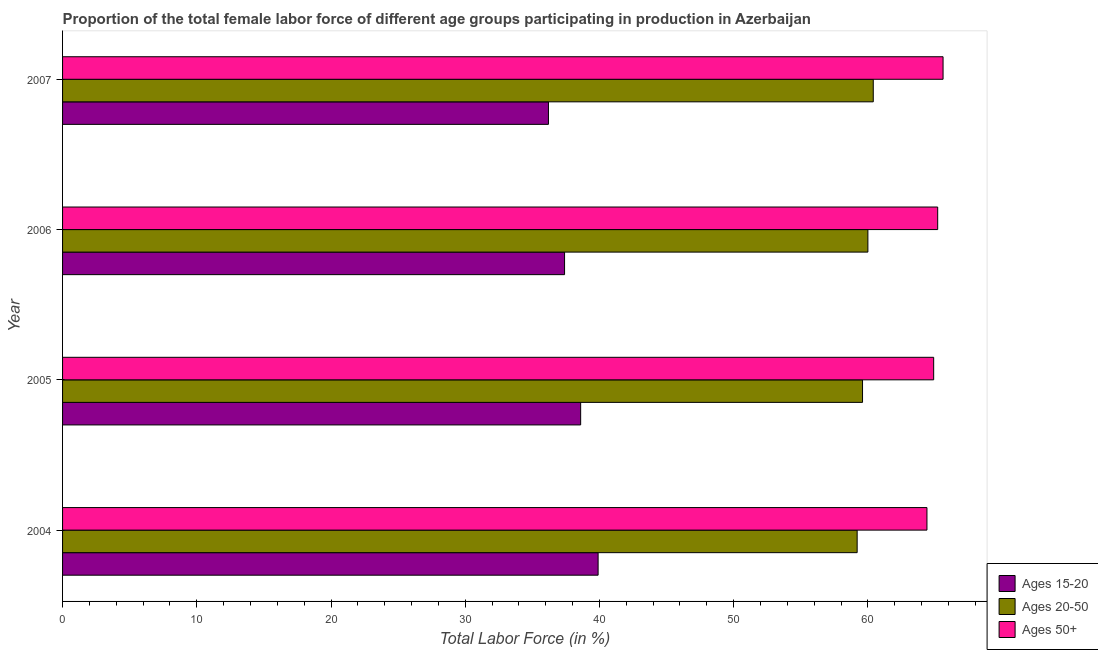How many different coloured bars are there?
Keep it short and to the point. 3. How many groups of bars are there?
Provide a succinct answer. 4. In how many cases, is the number of bars for a given year not equal to the number of legend labels?
Ensure brevity in your answer.  0. What is the percentage of female labor force within the age group 15-20 in 2005?
Provide a succinct answer. 38.6. Across all years, what is the maximum percentage of female labor force within the age group 15-20?
Give a very brief answer. 39.9. Across all years, what is the minimum percentage of female labor force within the age group 20-50?
Your response must be concise. 59.2. In which year was the percentage of female labor force within the age group 20-50 maximum?
Provide a short and direct response. 2007. In which year was the percentage of female labor force within the age group 20-50 minimum?
Your response must be concise. 2004. What is the total percentage of female labor force within the age group 15-20 in the graph?
Give a very brief answer. 152.1. What is the average percentage of female labor force within the age group 20-50 per year?
Offer a terse response. 59.8. In the year 2006, what is the difference between the percentage of female labor force within the age group 15-20 and percentage of female labor force within the age group 20-50?
Provide a short and direct response. -22.6. In how many years, is the percentage of female labor force within the age group 15-20 greater than 66 %?
Keep it short and to the point. 0. What is the difference between the highest and the second highest percentage of female labor force within the age group 15-20?
Give a very brief answer. 1.3. What is the difference between the highest and the lowest percentage of female labor force above age 50?
Offer a very short reply. 1.2. What does the 1st bar from the top in 2004 represents?
Offer a very short reply. Ages 50+. What does the 2nd bar from the bottom in 2007 represents?
Your answer should be very brief. Ages 20-50. Is it the case that in every year, the sum of the percentage of female labor force within the age group 15-20 and percentage of female labor force within the age group 20-50 is greater than the percentage of female labor force above age 50?
Offer a very short reply. Yes. How many bars are there?
Offer a terse response. 12. How many years are there in the graph?
Your response must be concise. 4. What is the difference between two consecutive major ticks on the X-axis?
Provide a succinct answer. 10. Are the values on the major ticks of X-axis written in scientific E-notation?
Give a very brief answer. No. How are the legend labels stacked?
Your response must be concise. Vertical. What is the title of the graph?
Make the answer very short. Proportion of the total female labor force of different age groups participating in production in Azerbaijan. Does "Ages 50+" appear as one of the legend labels in the graph?
Offer a terse response. Yes. What is the label or title of the Y-axis?
Offer a very short reply. Year. What is the Total Labor Force (in %) of Ages 15-20 in 2004?
Give a very brief answer. 39.9. What is the Total Labor Force (in %) in Ages 20-50 in 2004?
Ensure brevity in your answer.  59.2. What is the Total Labor Force (in %) in Ages 50+ in 2004?
Your response must be concise. 64.4. What is the Total Labor Force (in %) of Ages 15-20 in 2005?
Keep it short and to the point. 38.6. What is the Total Labor Force (in %) of Ages 20-50 in 2005?
Make the answer very short. 59.6. What is the Total Labor Force (in %) of Ages 50+ in 2005?
Your response must be concise. 64.9. What is the Total Labor Force (in %) of Ages 15-20 in 2006?
Ensure brevity in your answer.  37.4. What is the Total Labor Force (in %) in Ages 50+ in 2006?
Offer a very short reply. 65.2. What is the Total Labor Force (in %) in Ages 15-20 in 2007?
Provide a succinct answer. 36.2. What is the Total Labor Force (in %) in Ages 20-50 in 2007?
Your response must be concise. 60.4. What is the Total Labor Force (in %) in Ages 50+ in 2007?
Give a very brief answer. 65.6. Across all years, what is the maximum Total Labor Force (in %) in Ages 15-20?
Make the answer very short. 39.9. Across all years, what is the maximum Total Labor Force (in %) in Ages 20-50?
Your response must be concise. 60.4. Across all years, what is the maximum Total Labor Force (in %) of Ages 50+?
Keep it short and to the point. 65.6. Across all years, what is the minimum Total Labor Force (in %) in Ages 15-20?
Make the answer very short. 36.2. Across all years, what is the minimum Total Labor Force (in %) of Ages 20-50?
Your answer should be very brief. 59.2. Across all years, what is the minimum Total Labor Force (in %) of Ages 50+?
Offer a terse response. 64.4. What is the total Total Labor Force (in %) in Ages 15-20 in the graph?
Your response must be concise. 152.1. What is the total Total Labor Force (in %) in Ages 20-50 in the graph?
Provide a succinct answer. 239.2. What is the total Total Labor Force (in %) in Ages 50+ in the graph?
Provide a short and direct response. 260.1. What is the difference between the Total Labor Force (in %) of Ages 20-50 in 2004 and that in 2005?
Provide a succinct answer. -0.4. What is the difference between the Total Labor Force (in %) of Ages 50+ in 2004 and that in 2005?
Offer a very short reply. -0.5. What is the difference between the Total Labor Force (in %) of Ages 20-50 in 2004 and that in 2006?
Make the answer very short. -0.8. What is the difference between the Total Labor Force (in %) of Ages 50+ in 2004 and that in 2006?
Offer a terse response. -0.8. What is the difference between the Total Labor Force (in %) of Ages 15-20 in 2004 and that in 2007?
Offer a very short reply. 3.7. What is the difference between the Total Labor Force (in %) of Ages 20-50 in 2004 and that in 2007?
Keep it short and to the point. -1.2. What is the difference between the Total Labor Force (in %) of Ages 50+ in 2004 and that in 2007?
Your answer should be very brief. -1.2. What is the difference between the Total Labor Force (in %) of Ages 15-20 in 2005 and that in 2006?
Provide a short and direct response. 1.2. What is the difference between the Total Labor Force (in %) in Ages 50+ in 2005 and that in 2006?
Ensure brevity in your answer.  -0.3. What is the difference between the Total Labor Force (in %) of Ages 20-50 in 2005 and that in 2007?
Your answer should be very brief. -0.8. What is the difference between the Total Labor Force (in %) of Ages 50+ in 2005 and that in 2007?
Your answer should be very brief. -0.7. What is the difference between the Total Labor Force (in %) of Ages 15-20 in 2006 and that in 2007?
Keep it short and to the point. 1.2. What is the difference between the Total Labor Force (in %) in Ages 20-50 in 2006 and that in 2007?
Offer a very short reply. -0.4. What is the difference between the Total Labor Force (in %) in Ages 15-20 in 2004 and the Total Labor Force (in %) in Ages 20-50 in 2005?
Ensure brevity in your answer.  -19.7. What is the difference between the Total Labor Force (in %) in Ages 15-20 in 2004 and the Total Labor Force (in %) in Ages 50+ in 2005?
Give a very brief answer. -25. What is the difference between the Total Labor Force (in %) in Ages 20-50 in 2004 and the Total Labor Force (in %) in Ages 50+ in 2005?
Your answer should be very brief. -5.7. What is the difference between the Total Labor Force (in %) in Ages 15-20 in 2004 and the Total Labor Force (in %) in Ages 20-50 in 2006?
Your answer should be compact. -20.1. What is the difference between the Total Labor Force (in %) of Ages 15-20 in 2004 and the Total Labor Force (in %) of Ages 50+ in 2006?
Your answer should be compact. -25.3. What is the difference between the Total Labor Force (in %) in Ages 15-20 in 2004 and the Total Labor Force (in %) in Ages 20-50 in 2007?
Offer a terse response. -20.5. What is the difference between the Total Labor Force (in %) of Ages 15-20 in 2004 and the Total Labor Force (in %) of Ages 50+ in 2007?
Give a very brief answer. -25.7. What is the difference between the Total Labor Force (in %) in Ages 15-20 in 2005 and the Total Labor Force (in %) in Ages 20-50 in 2006?
Provide a succinct answer. -21.4. What is the difference between the Total Labor Force (in %) of Ages 15-20 in 2005 and the Total Labor Force (in %) of Ages 50+ in 2006?
Your response must be concise. -26.6. What is the difference between the Total Labor Force (in %) in Ages 15-20 in 2005 and the Total Labor Force (in %) in Ages 20-50 in 2007?
Your answer should be very brief. -21.8. What is the difference between the Total Labor Force (in %) in Ages 20-50 in 2005 and the Total Labor Force (in %) in Ages 50+ in 2007?
Offer a terse response. -6. What is the difference between the Total Labor Force (in %) in Ages 15-20 in 2006 and the Total Labor Force (in %) in Ages 50+ in 2007?
Provide a succinct answer. -28.2. What is the difference between the Total Labor Force (in %) of Ages 20-50 in 2006 and the Total Labor Force (in %) of Ages 50+ in 2007?
Make the answer very short. -5.6. What is the average Total Labor Force (in %) in Ages 15-20 per year?
Provide a succinct answer. 38.02. What is the average Total Labor Force (in %) of Ages 20-50 per year?
Keep it short and to the point. 59.8. What is the average Total Labor Force (in %) of Ages 50+ per year?
Give a very brief answer. 65.03. In the year 2004, what is the difference between the Total Labor Force (in %) of Ages 15-20 and Total Labor Force (in %) of Ages 20-50?
Ensure brevity in your answer.  -19.3. In the year 2004, what is the difference between the Total Labor Force (in %) in Ages 15-20 and Total Labor Force (in %) in Ages 50+?
Your answer should be very brief. -24.5. In the year 2004, what is the difference between the Total Labor Force (in %) of Ages 20-50 and Total Labor Force (in %) of Ages 50+?
Offer a very short reply. -5.2. In the year 2005, what is the difference between the Total Labor Force (in %) of Ages 15-20 and Total Labor Force (in %) of Ages 50+?
Your answer should be very brief. -26.3. In the year 2005, what is the difference between the Total Labor Force (in %) of Ages 20-50 and Total Labor Force (in %) of Ages 50+?
Your answer should be compact. -5.3. In the year 2006, what is the difference between the Total Labor Force (in %) in Ages 15-20 and Total Labor Force (in %) in Ages 20-50?
Offer a terse response. -22.6. In the year 2006, what is the difference between the Total Labor Force (in %) of Ages 15-20 and Total Labor Force (in %) of Ages 50+?
Provide a succinct answer. -27.8. In the year 2006, what is the difference between the Total Labor Force (in %) of Ages 20-50 and Total Labor Force (in %) of Ages 50+?
Offer a very short reply. -5.2. In the year 2007, what is the difference between the Total Labor Force (in %) of Ages 15-20 and Total Labor Force (in %) of Ages 20-50?
Provide a short and direct response. -24.2. In the year 2007, what is the difference between the Total Labor Force (in %) in Ages 15-20 and Total Labor Force (in %) in Ages 50+?
Your answer should be very brief. -29.4. What is the ratio of the Total Labor Force (in %) in Ages 15-20 in 2004 to that in 2005?
Provide a short and direct response. 1.03. What is the ratio of the Total Labor Force (in %) in Ages 20-50 in 2004 to that in 2005?
Keep it short and to the point. 0.99. What is the ratio of the Total Labor Force (in %) of Ages 50+ in 2004 to that in 2005?
Offer a very short reply. 0.99. What is the ratio of the Total Labor Force (in %) in Ages 15-20 in 2004 to that in 2006?
Offer a very short reply. 1.07. What is the ratio of the Total Labor Force (in %) of Ages 20-50 in 2004 to that in 2006?
Ensure brevity in your answer.  0.99. What is the ratio of the Total Labor Force (in %) of Ages 50+ in 2004 to that in 2006?
Your answer should be compact. 0.99. What is the ratio of the Total Labor Force (in %) in Ages 15-20 in 2004 to that in 2007?
Provide a succinct answer. 1.1. What is the ratio of the Total Labor Force (in %) of Ages 20-50 in 2004 to that in 2007?
Make the answer very short. 0.98. What is the ratio of the Total Labor Force (in %) in Ages 50+ in 2004 to that in 2007?
Make the answer very short. 0.98. What is the ratio of the Total Labor Force (in %) in Ages 15-20 in 2005 to that in 2006?
Your response must be concise. 1.03. What is the ratio of the Total Labor Force (in %) of Ages 50+ in 2005 to that in 2006?
Ensure brevity in your answer.  1. What is the ratio of the Total Labor Force (in %) in Ages 15-20 in 2005 to that in 2007?
Make the answer very short. 1.07. What is the ratio of the Total Labor Force (in %) in Ages 50+ in 2005 to that in 2007?
Your answer should be very brief. 0.99. What is the ratio of the Total Labor Force (in %) of Ages 15-20 in 2006 to that in 2007?
Your response must be concise. 1.03. What is the ratio of the Total Labor Force (in %) in Ages 50+ in 2006 to that in 2007?
Keep it short and to the point. 0.99. What is the difference between the highest and the second highest Total Labor Force (in %) in Ages 50+?
Make the answer very short. 0.4. What is the difference between the highest and the lowest Total Labor Force (in %) in Ages 15-20?
Make the answer very short. 3.7. What is the difference between the highest and the lowest Total Labor Force (in %) in Ages 20-50?
Offer a very short reply. 1.2. What is the difference between the highest and the lowest Total Labor Force (in %) in Ages 50+?
Ensure brevity in your answer.  1.2. 